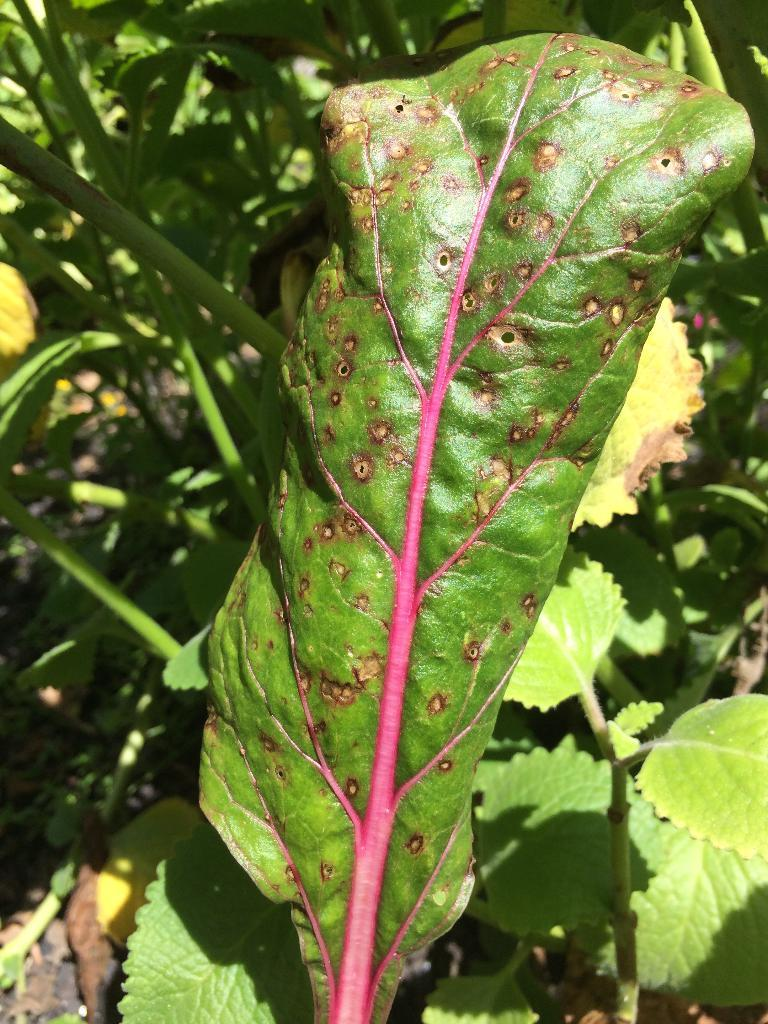What type of vegetation can be seen in the image? There are plants and trees in the image. Can you describe the plants and trees in the image? The image shows plants and trees, but specific details cannot be provided without additional information. What sign is displayed on the tree in the image? There is no sign present on the tree in the image. How does the digestion process of the plants in the image work? The image does not provide information about the digestion process of the plants; it only shows their presence. 